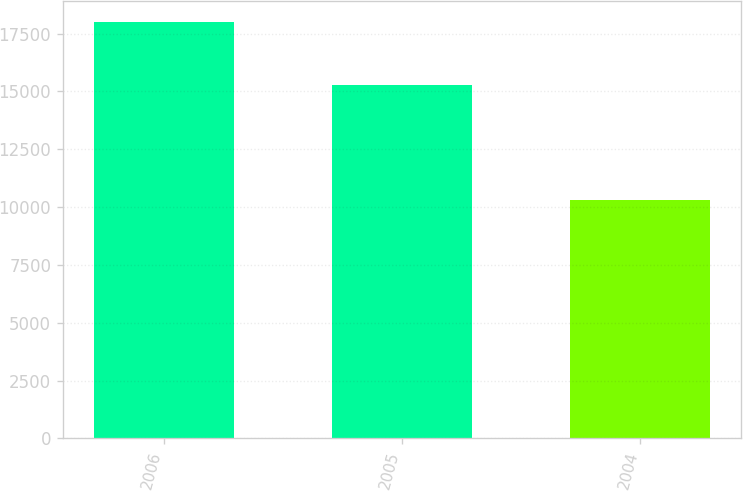Convert chart. <chart><loc_0><loc_0><loc_500><loc_500><bar_chart><fcel>2006<fcel>2005<fcel>2004<nl><fcel>17992.7<fcel>15274.8<fcel>10296.4<nl></chart> 